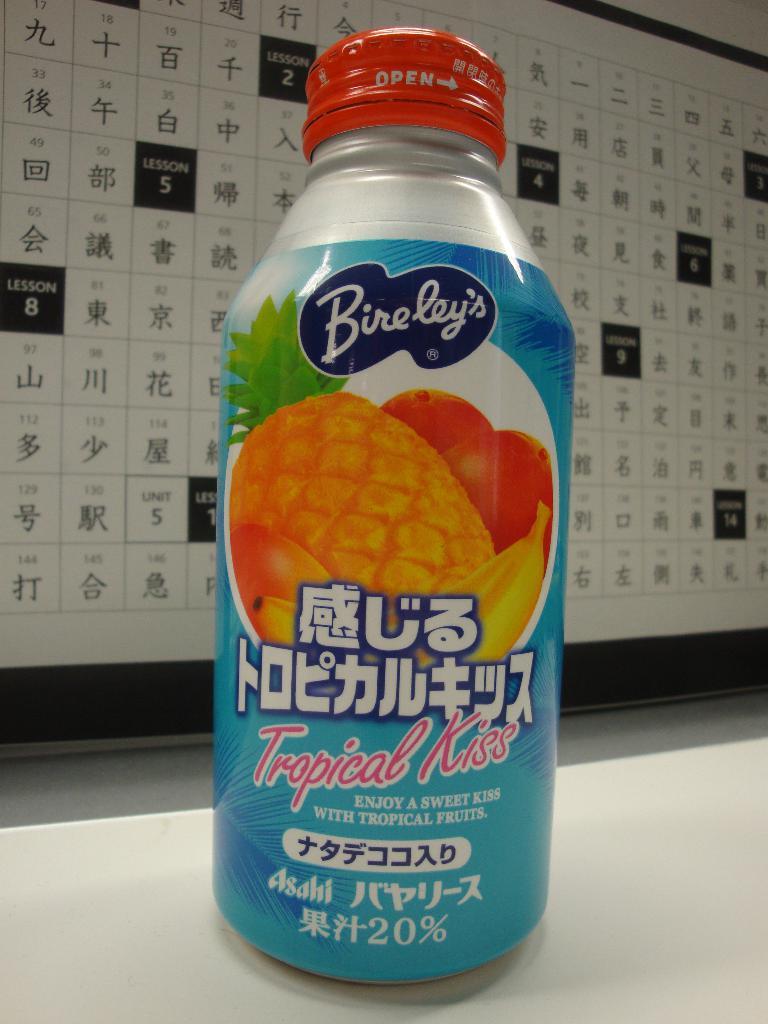What flavor is this drink?
Your answer should be compact. Tropical kiss. 